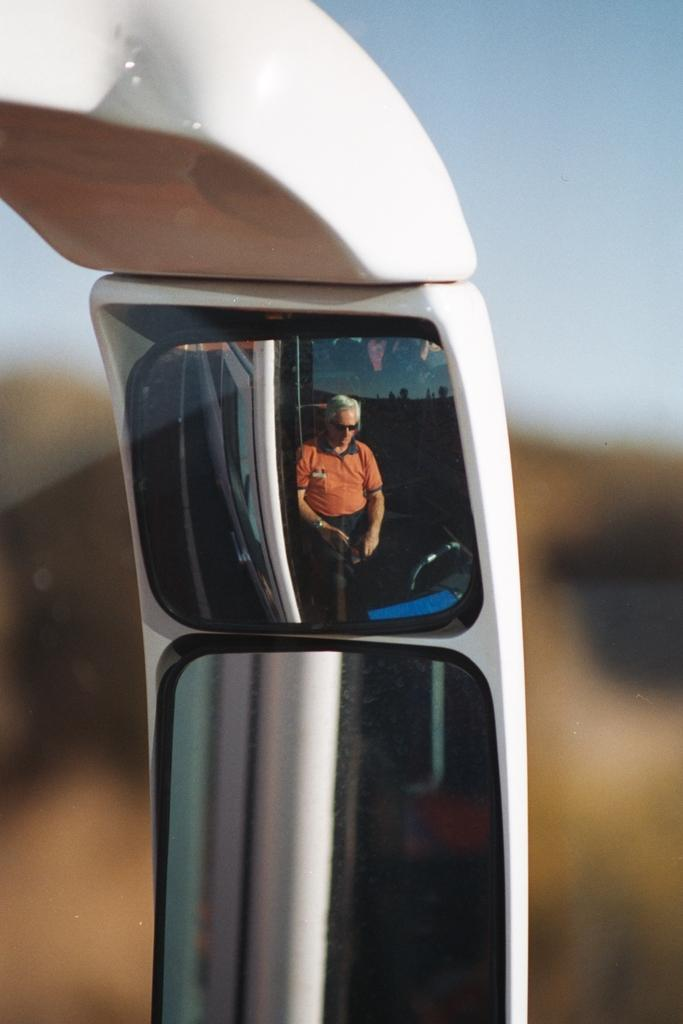What object is present in the image that can create reflections? There is a mirror in the image. What can be seen in the mirror's reflection? The mirror reflects a man. How would you describe the background of the mirror's reflection? The background of the mirror reflection is blurry. What type of border can be seen around the mirror in the image? There is no mention of a border around the mirror in the provided facts, so it cannot be determined from the image. 